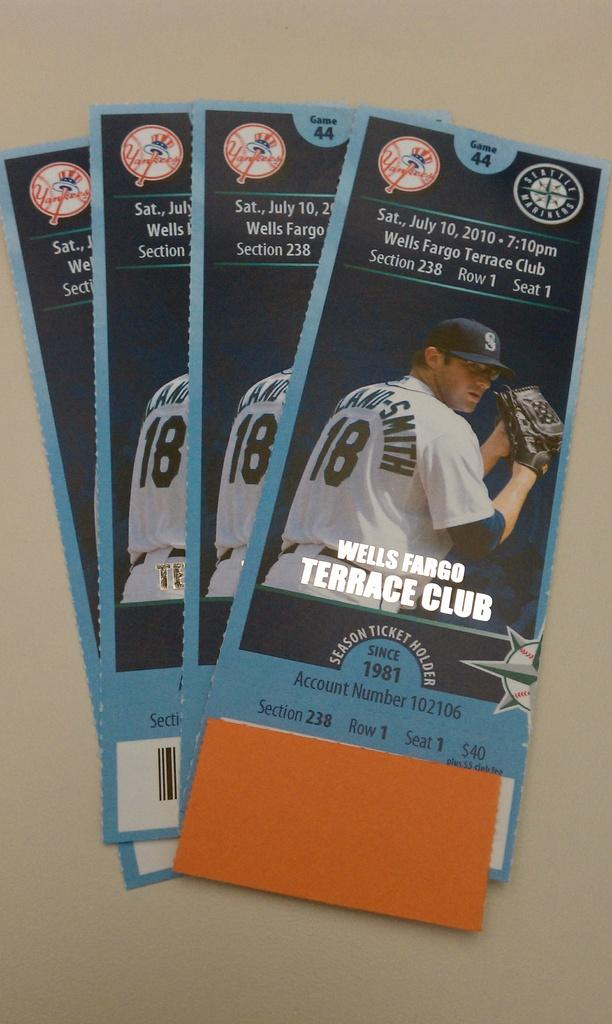Provide a one-sentence caption for the provided image. A stack of baseball tickets for the Seattle Mariners game on July 10, 2010. 